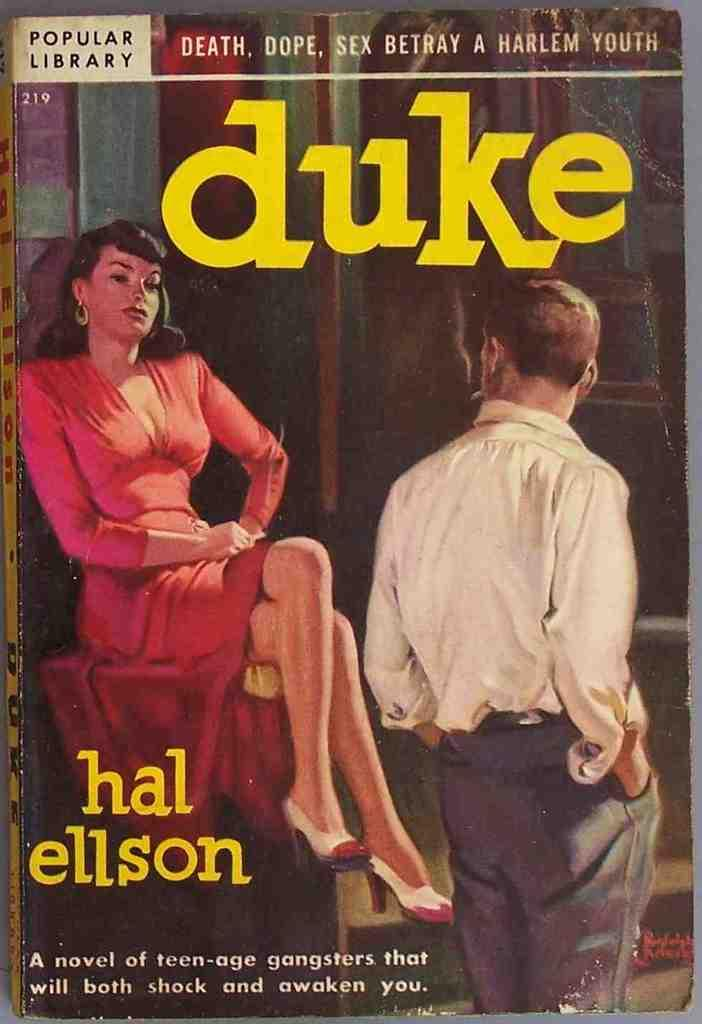<image>
Summarize the visual content of the image. An old book by Hal Ellson has a man looking towards a well dressed woman on it. 